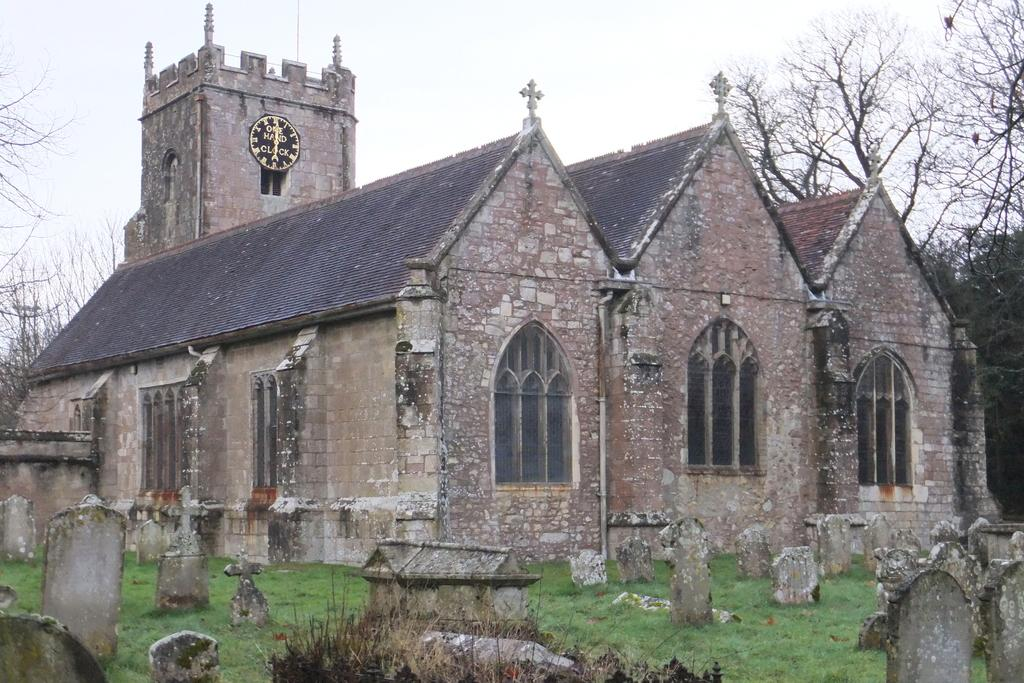What type of structures are located in the middle of the image? There are houses in the middle of the image. What can be seen at the bottom of the image? There are graveyards at the bottom of the image. What is on the right side of the image? There is a tree on the right side of the image. What is visible at the top of the image? The sky is visible at the top of the image. What is the sister writing in the image? There is no sister present in the image, and therefore no writing can be observed. What season is depicted in the image? The provided facts do not mention any seasonal details, so it cannot be determined from the image. 